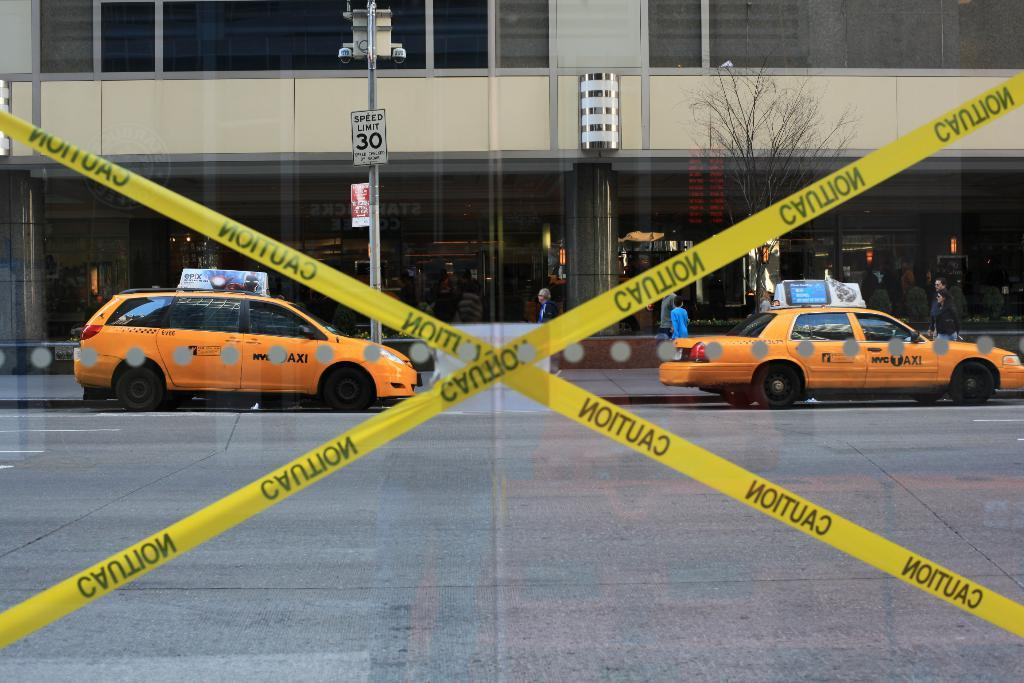Provide a one-sentence caption for the provided image. Caution tape blocks off an area in front of 2 orange cars and a building. 